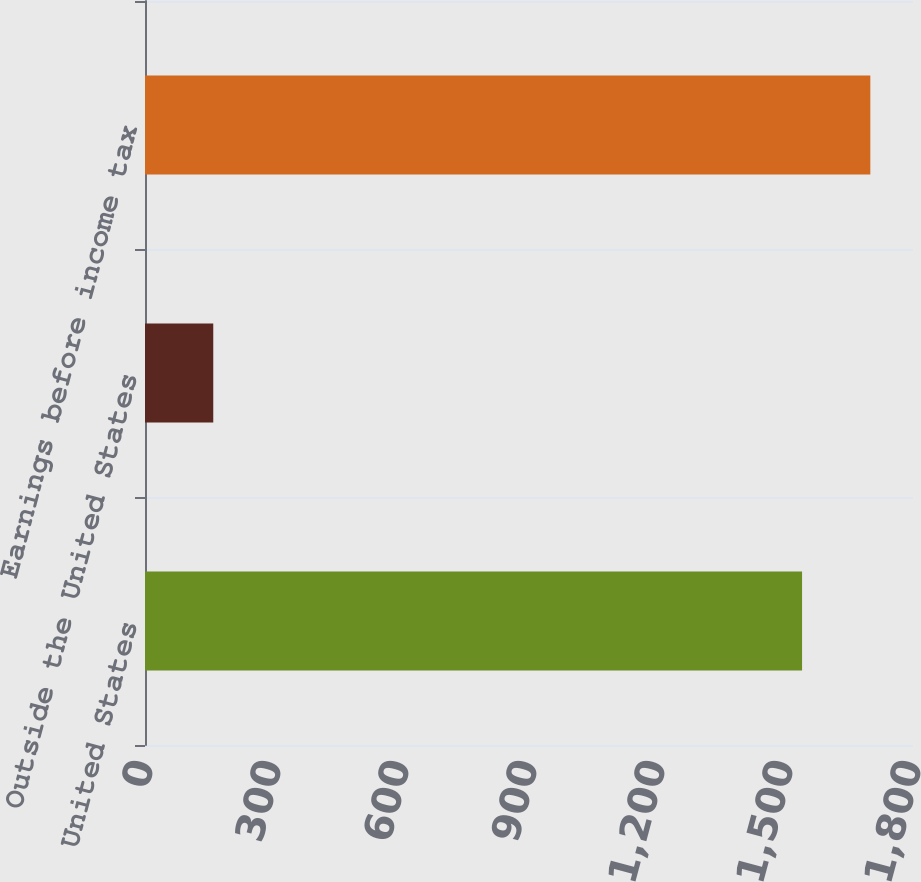<chart> <loc_0><loc_0><loc_500><loc_500><bar_chart><fcel>United States<fcel>Outside the United States<fcel>Earnings before income tax<nl><fcel>1540<fcel>160<fcel>1700<nl></chart> 